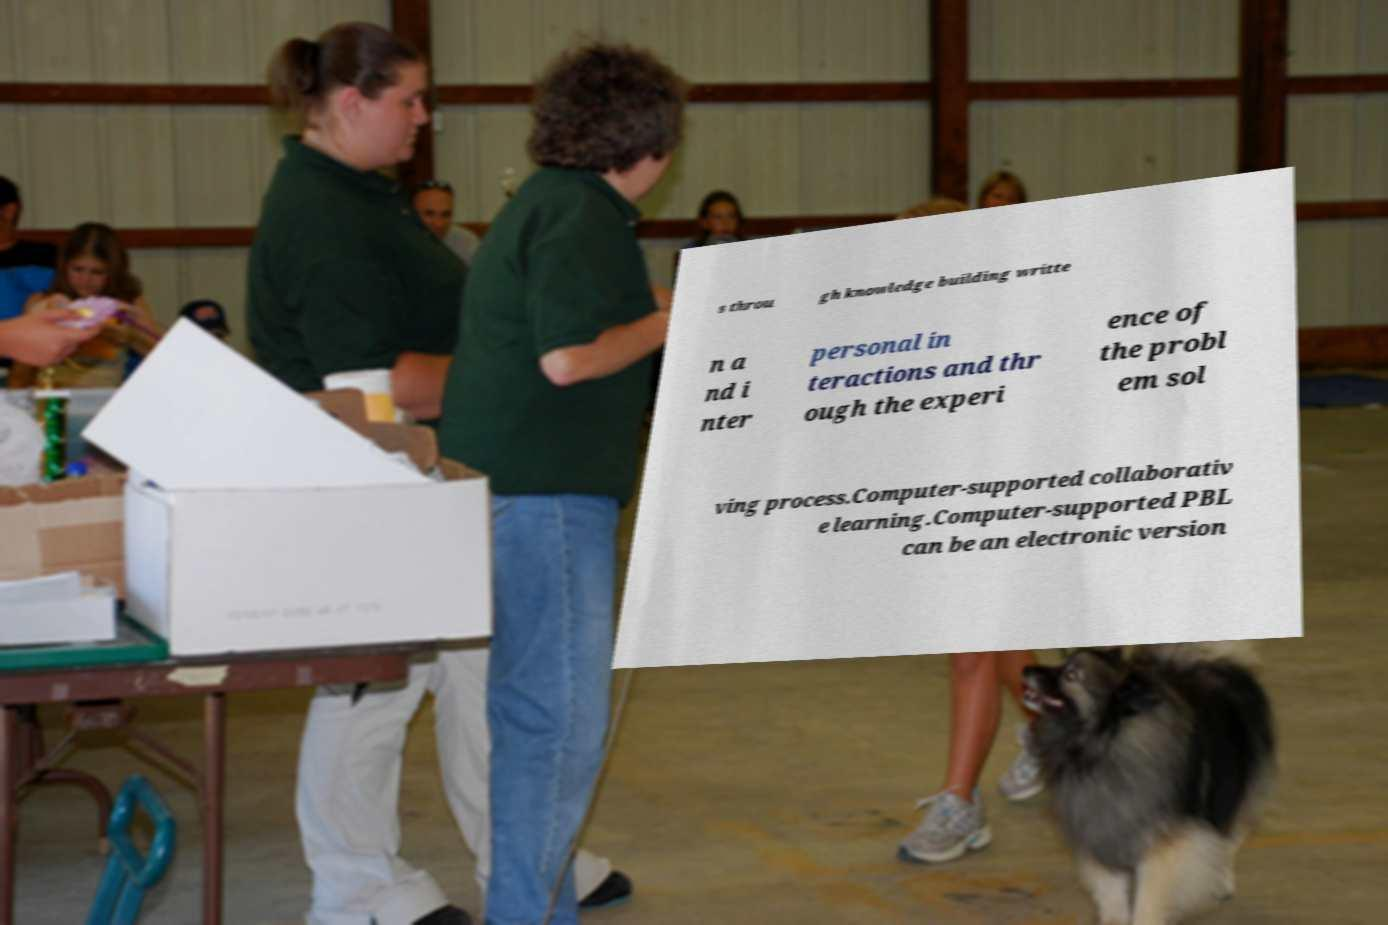Can you accurately transcribe the text from the provided image for me? s throu gh knowledge building writte n a nd i nter personal in teractions and thr ough the experi ence of the probl em sol ving process.Computer-supported collaborativ e learning.Computer-supported PBL can be an electronic version 